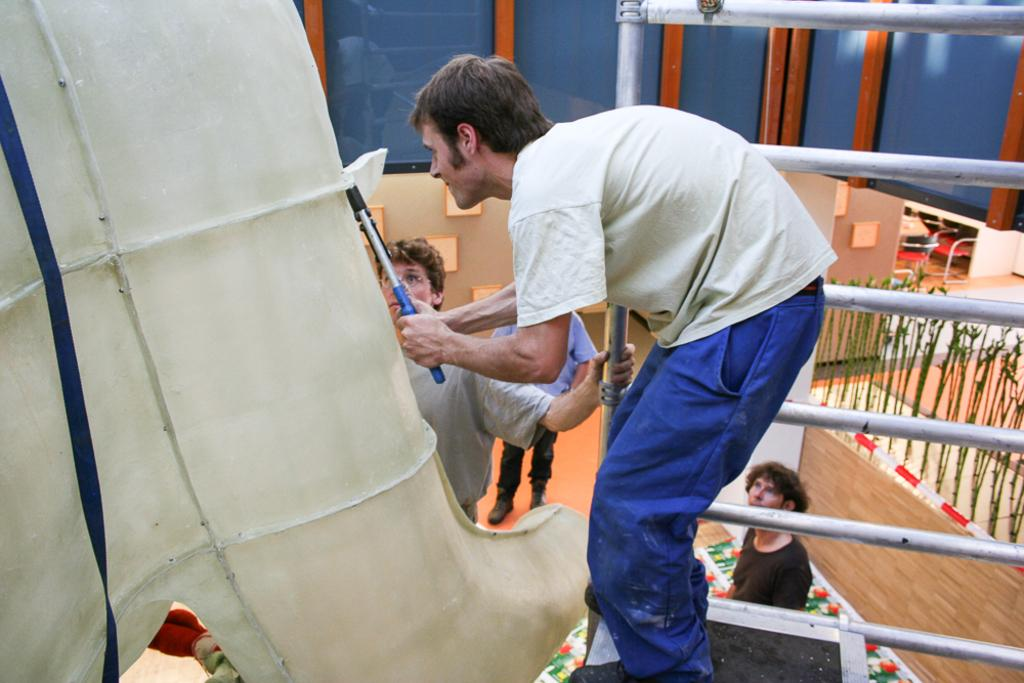What is the person holding in the image? There is a person holding an object in the image. What can be seen in the foreground of the image? There is a big pipe in the foreground of the image. What is visible in the background of the image? There are people, objects, a wall, and rods in the background of the image. What is the surface on which the person and objects are placed? The floor is visible in the image. What type of marble is being used for teaching in the image? There is no marble or teaching activity present in the image. 